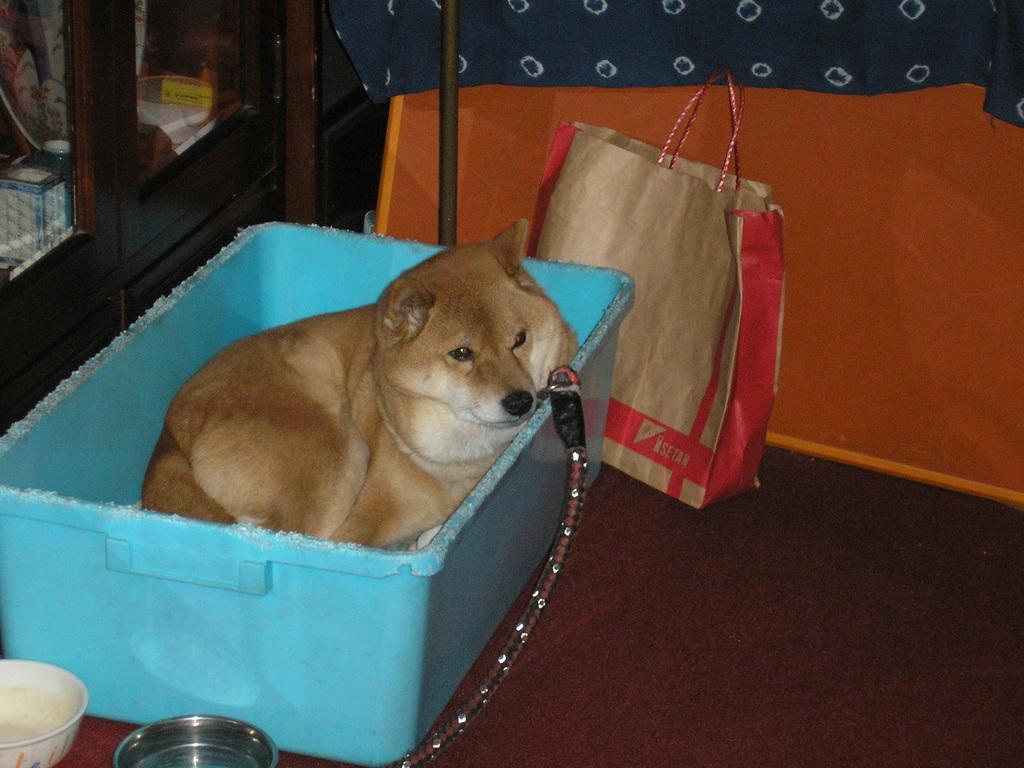Can you describe this image briefly? In this image we can see a basket. Inside the basket there is a dog. Near to the basket there are bowls and a packet. On the left side there is a cupboard. Inside that there are many items. 